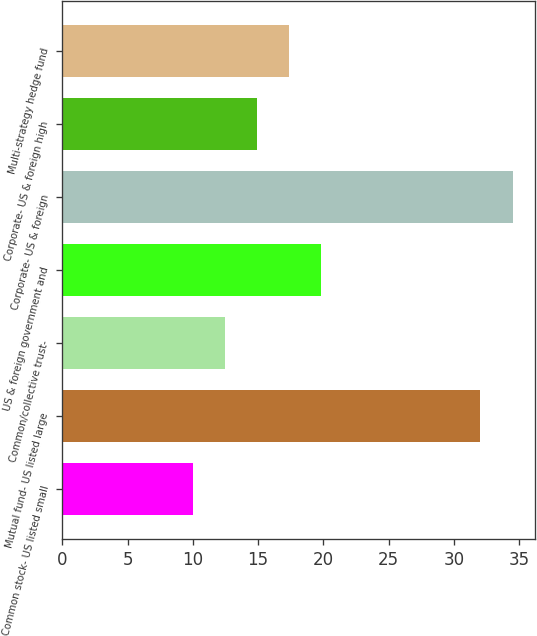Convert chart to OTSL. <chart><loc_0><loc_0><loc_500><loc_500><bar_chart><fcel>Common stock- US listed small<fcel>Mutual fund- US listed large<fcel>Common/collective trust-<fcel>US & foreign government and<fcel>Corporate- US & foreign<fcel>Corporate- US & foreign high<fcel>Multi-strategy hedge fund<nl><fcel>10<fcel>32<fcel>12.45<fcel>19.8<fcel>34.5<fcel>14.9<fcel>17.35<nl></chart> 